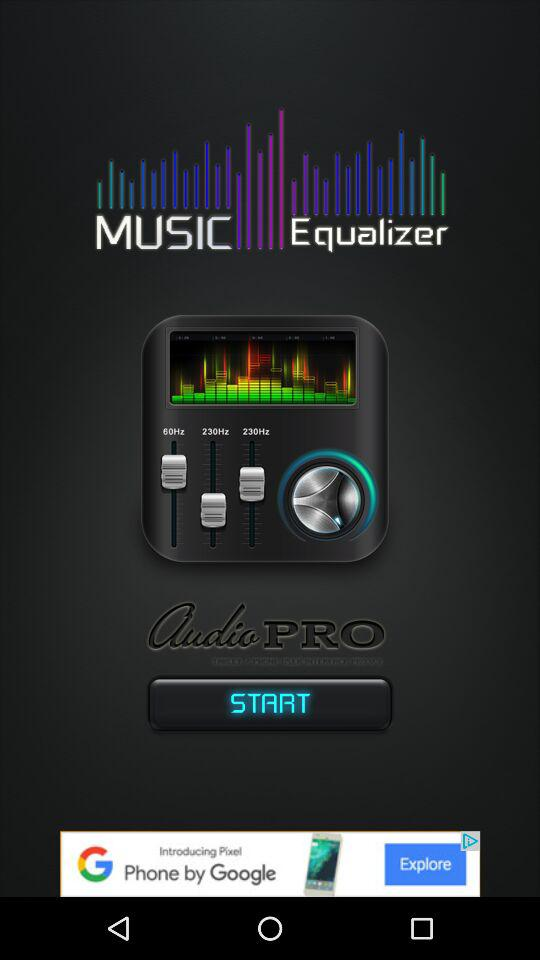What is the app name? The app name is "MUSIC Equalizer". 